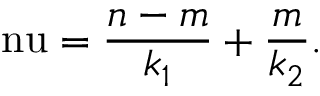<formula> <loc_0><loc_0><loc_500><loc_500>\ n u = \frac { n - m } { k _ { 1 } } + \frac { m } { k _ { 2 } } .</formula> 